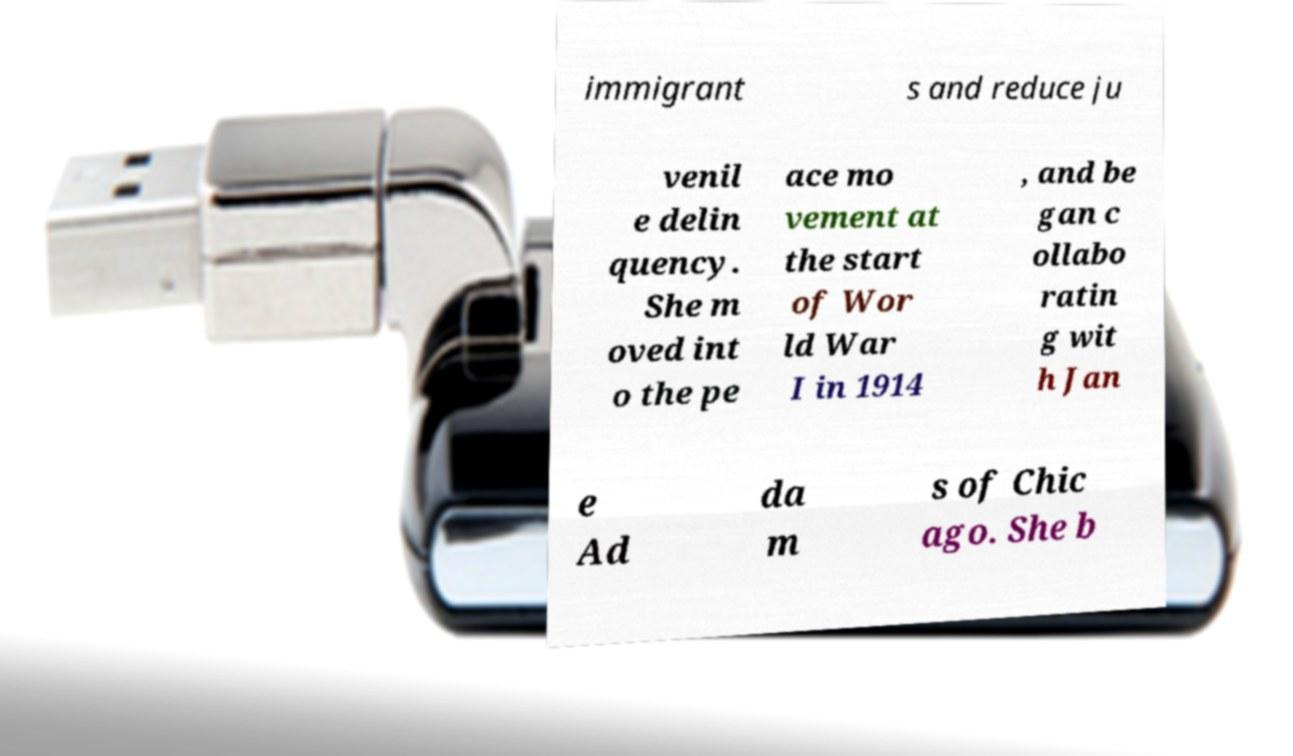Can you accurately transcribe the text from the provided image for me? immigrant s and reduce ju venil e delin quency. She m oved int o the pe ace mo vement at the start of Wor ld War I in 1914 , and be gan c ollabo ratin g wit h Jan e Ad da m s of Chic ago. She b 